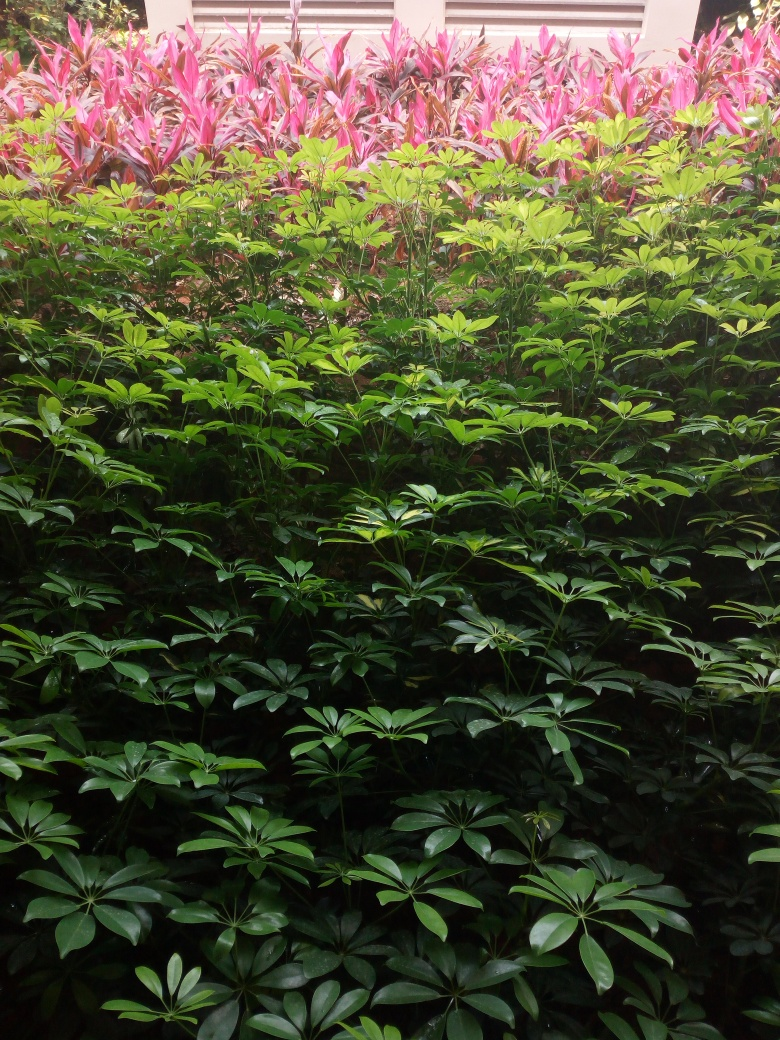What types of plants are shown in this image? The image features a variety of plants, predominantly showcasing broadleaf evergreens which could include species such as Schefflera or similar ornamental shrubs. In the background, there are plants with pink and red leaves that could be part of the Cordyline genus, known for their colorful foliage. 